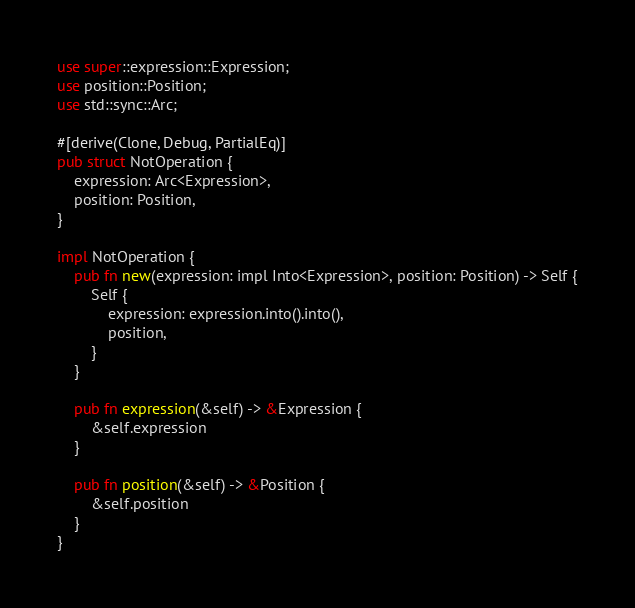Convert code to text. <code><loc_0><loc_0><loc_500><loc_500><_Rust_>use super::expression::Expression;
use position::Position;
use std::sync::Arc;

#[derive(Clone, Debug, PartialEq)]
pub struct NotOperation {
    expression: Arc<Expression>,
    position: Position,
}

impl NotOperation {
    pub fn new(expression: impl Into<Expression>, position: Position) -> Self {
        Self {
            expression: expression.into().into(),
            position,
        }
    }

    pub fn expression(&self) -> &Expression {
        &self.expression
    }

    pub fn position(&self) -> &Position {
        &self.position
    }
}
</code> 